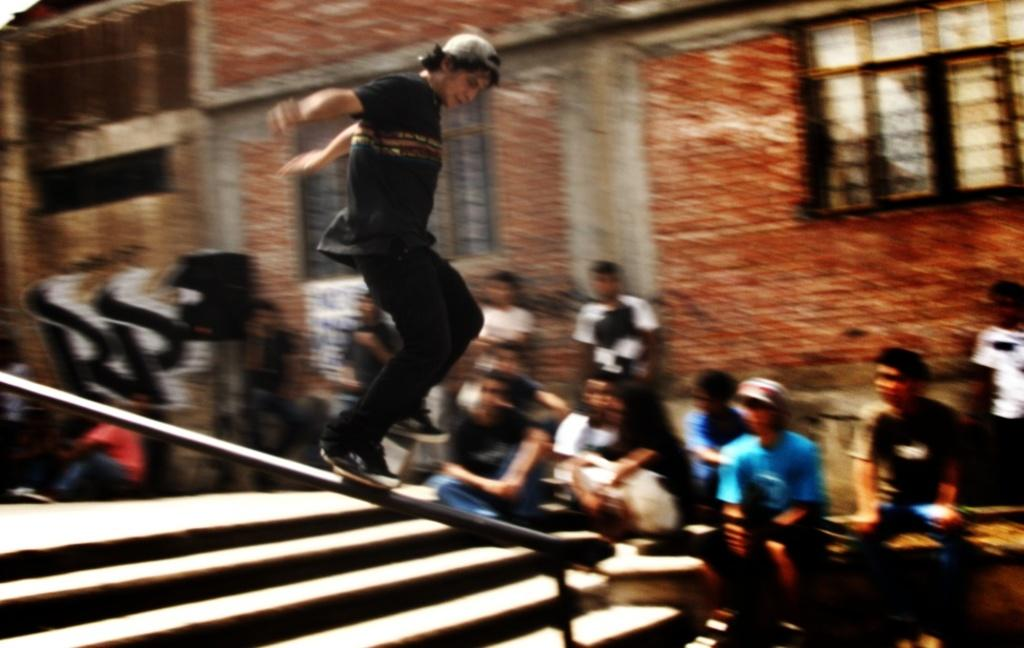What is the main activity of the person in the image? There is a person skating in the image. What architectural feature can be seen in the image? There are stairs in the image. What is happening in the background of the image? There are other people sitting in the backdrop of the image. What type of structure is visible in the background? There is a building in the backdrop of the image. What type of copper material is being used to create a sense of disgust in the image? There is no copper material or sense of disgust present in the image. 